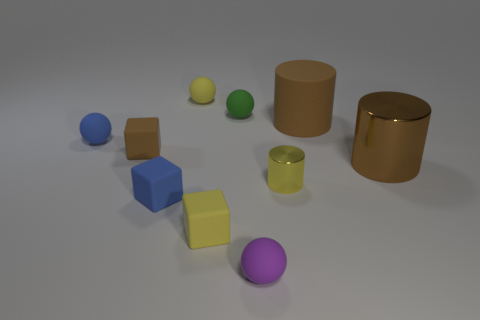Are there fewer metal cylinders that are on the right side of the tiny yellow cylinder than spheres in front of the green ball?
Keep it short and to the point. Yes. What number of spheres are either yellow matte objects or tiny objects?
Give a very brief answer. 4. Does the small sphere behind the tiny green sphere have the same material as the large thing that is behind the brown cube?
Keep it short and to the point. Yes. There is a brown object that is the same size as the yellow metal cylinder; what shape is it?
Keep it short and to the point. Cube. What number of other objects are the same color as the large metallic cylinder?
Keep it short and to the point. 2. How many purple objects are either matte spheres or tiny cylinders?
Your response must be concise. 1. There is a tiny yellow matte object in front of the blue block; does it have the same shape as the brown rubber thing left of the tiny green matte sphere?
Your answer should be very brief. Yes. How many other things are the same material as the purple thing?
Ensure brevity in your answer.  7. There is a tiny yellow thing on the right side of the ball that is in front of the tiny yellow cylinder; are there any brown matte blocks that are on the right side of it?
Give a very brief answer. No. Do the purple sphere and the green object have the same material?
Make the answer very short. Yes. 